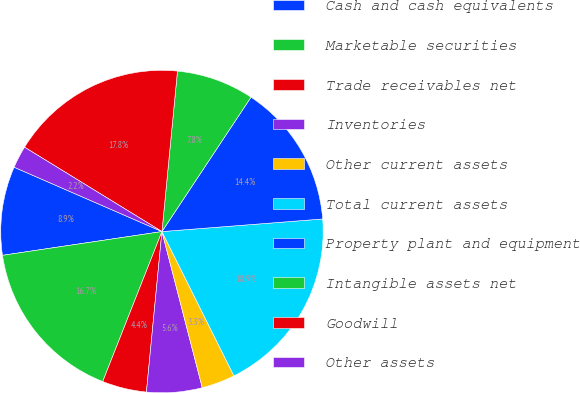<chart> <loc_0><loc_0><loc_500><loc_500><pie_chart><fcel>Cash and cash equivalents<fcel>Marketable securities<fcel>Trade receivables net<fcel>Inventories<fcel>Other current assets<fcel>Total current assets<fcel>Property plant and equipment<fcel>Intangible assets net<fcel>Goodwill<fcel>Other assets<nl><fcel>8.89%<fcel>16.66%<fcel>4.45%<fcel>5.56%<fcel>3.34%<fcel>18.88%<fcel>14.44%<fcel>7.78%<fcel>17.77%<fcel>2.23%<nl></chart> 